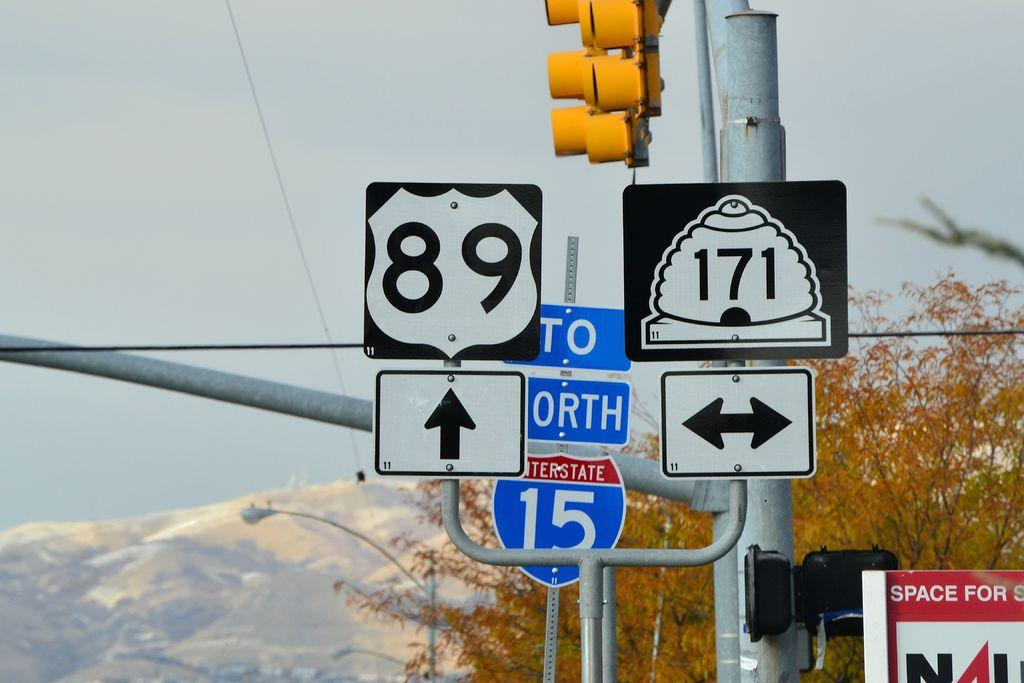<image>
Create a compact narrative representing the image presented. Some road signs, one of which has the number 89 on it 